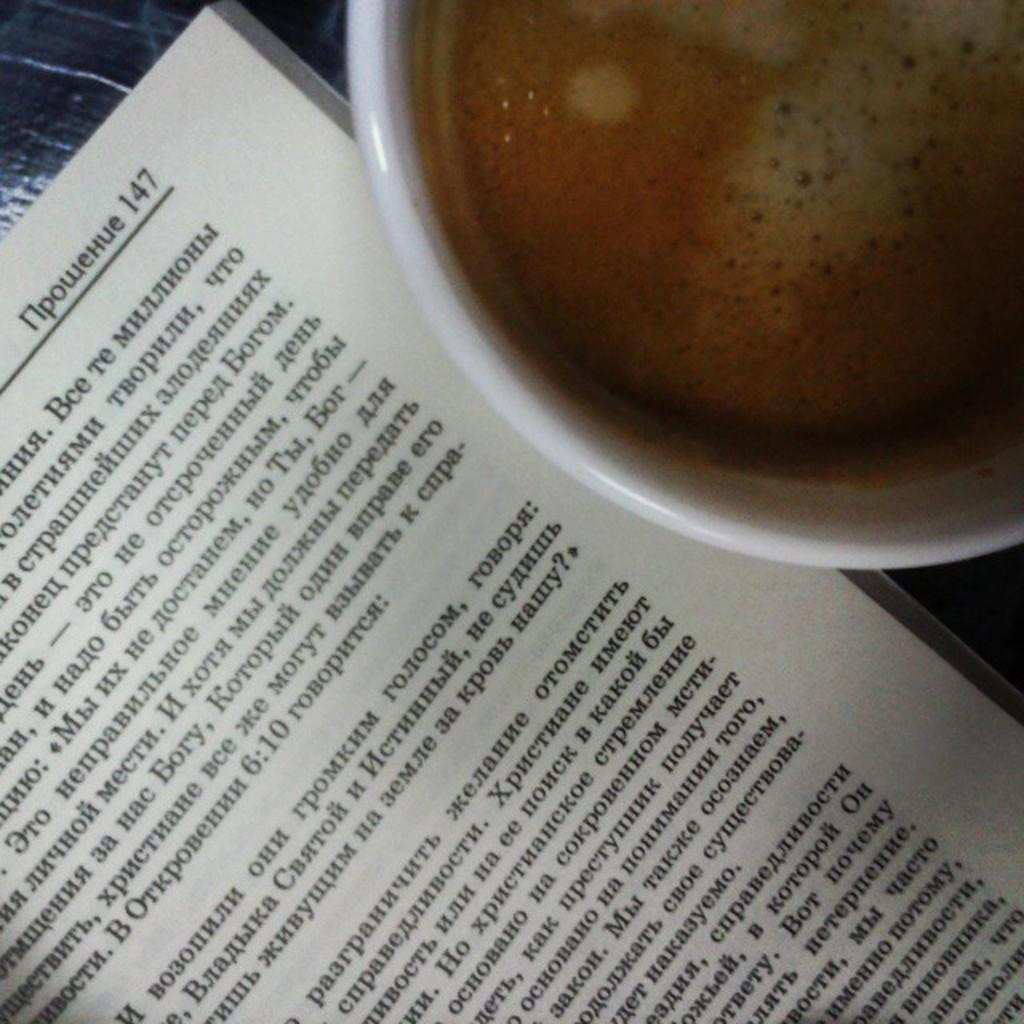<image>
Share a concise interpretation of the image provided. A book opened to page 147 next to a cup of coffee. 